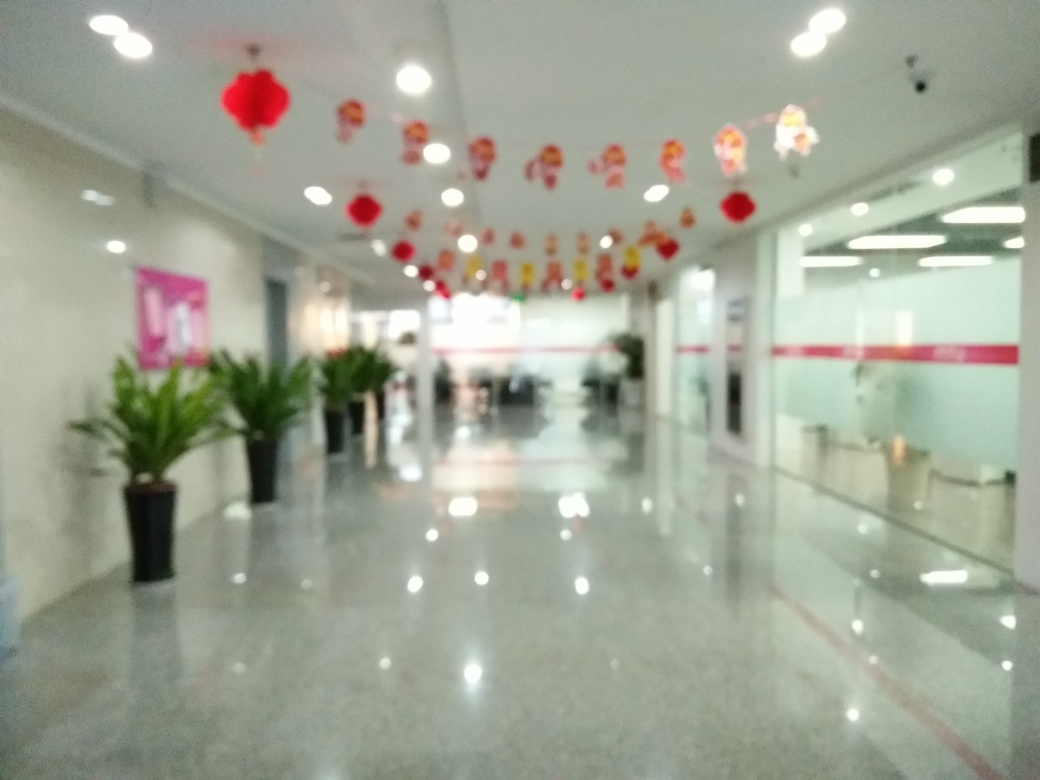Is the main subject, the corridor, very blurry? Indeed, the main subject, which is the corridor in the image, appears quite blurry. The focus seems to be off, making the details of the corridor, such as the floor, walls, ceiling, and the decorations hanging from it, difficult to discern clearly. This effect can sometimes be intentional in photography to create a specific mood or style, but it can also be due to technical limitations or errors during the shot. The depth of field is shallow, leading to the blurriness of objects both in the foreground and the background. 